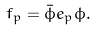<formula> <loc_0><loc_0><loc_500><loc_500>f _ { p } = \bar { \phi } e _ { p } \phi .</formula> 